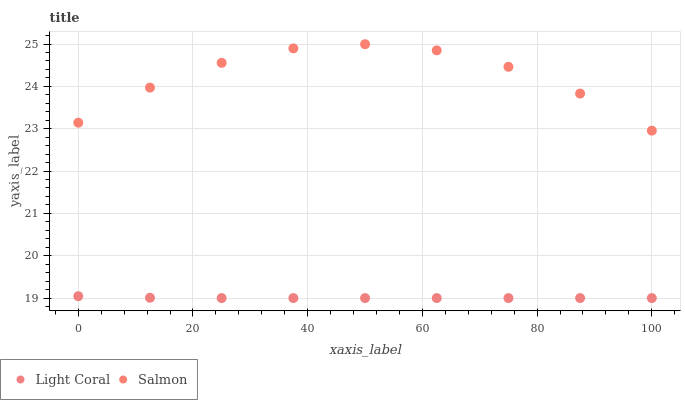Does Light Coral have the minimum area under the curve?
Answer yes or no. Yes. Does Salmon have the maximum area under the curve?
Answer yes or no. Yes. Does Salmon have the minimum area under the curve?
Answer yes or no. No. Is Light Coral the smoothest?
Answer yes or no. Yes. Is Salmon the roughest?
Answer yes or no. Yes. Is Salmon the smoothest?
Answer yes or no. No. Does Light Coral have the lowest value?
Answer yes or no. Yes. Does Salmon have the lowest value?
Answer yes or no. No. Does Salmon have the highest value?
Answer yes or no. Yes. Is Light Coral less than Salmon?
Answer yes or no. Yes. Is Salmon greater than Light Coral?
Answer yes or no. Yes. Does Light Coral intersect Salmon?
Answer yes or no. No. 